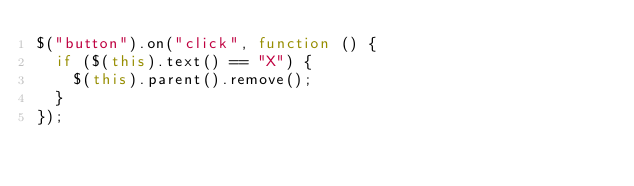Convert code to text. <code><loc_0><loc_0><loc_500><loc_500><_JavaScript_>$("button").on("click", function () {
  if ($(this).text() == "X") {
    $(this).parent().remove();
  }
});
</code> 